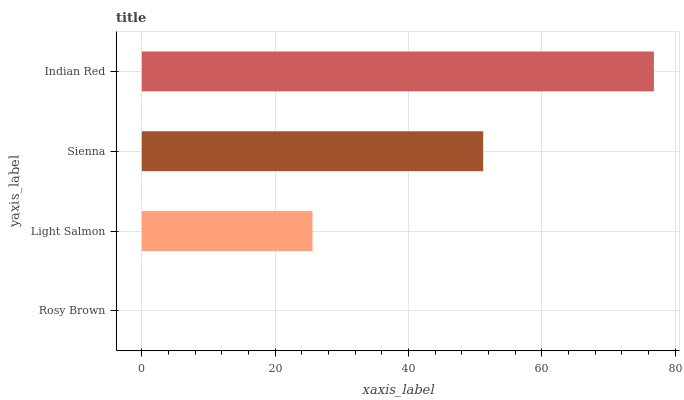Is Rosy Brown the minimum?
Answer yes or no. Yes. Is Indian Red the maximum?
Answer yes or no. Yes. Is Light Salmon the minimum?
Answer yes or no. No. Is Light Salmon the maximum?
Answer yes or no. No. Is Light Salmon greater than Rosy Brown?
Answer yes or no. Yes. Is Rosy Brown less than Light Salmon?
Answer yes or no. Yes. Is Rosy Brown greater than Light Salmon?
Answer yes or no. No. Is Light Salmon less than Rosy Brown?
Answer yes or no. No. Is Sienna the high median?
Answer yes or no. Yes. Is Light Salmon the low median?
Answer yes or no. Yes. Is Rosy Brown the high median?
Answer yes or no. No. Is Sienna the low median?
Answer yes or no. No. 